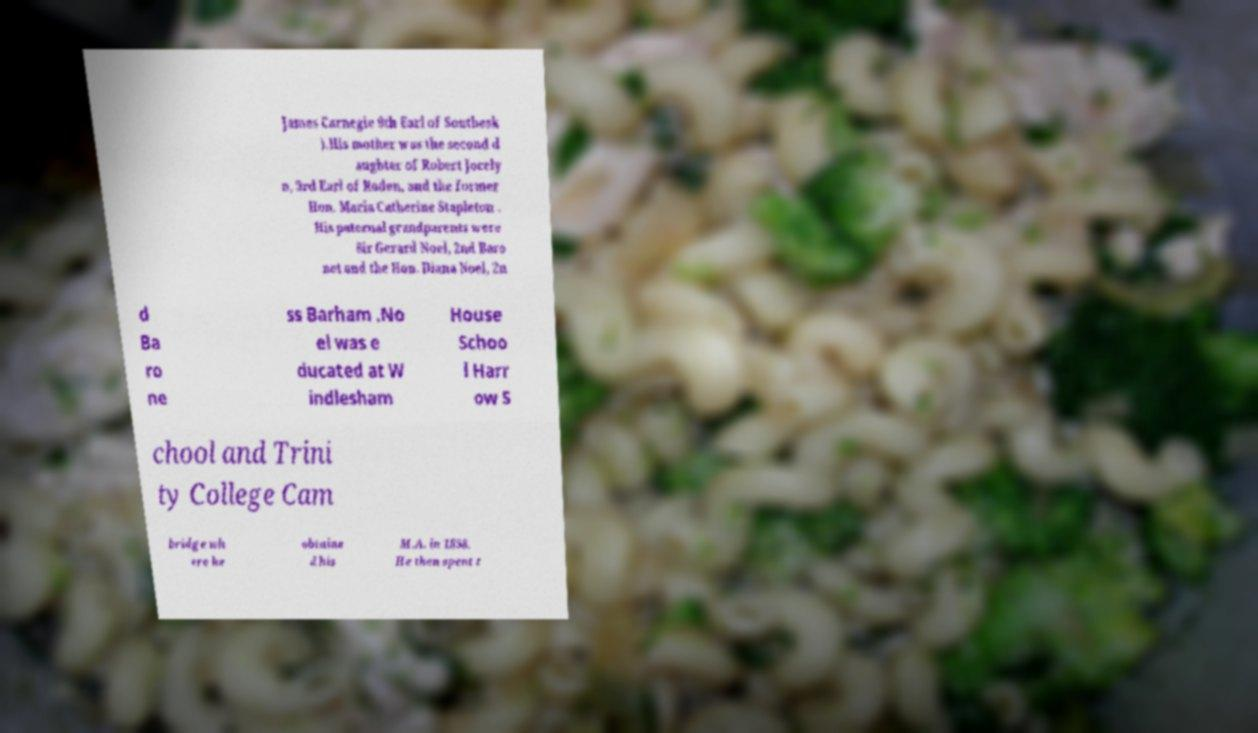For documentation purposes, I need the text within this image transcribed. Could you provide that? James Carnegie 9th Earl of Southesk ).His mother was the second d aughter of Robert Jocely n, 3rd Earl of Roden, and the former Hon. Maria Catherine Stapleton . His paternal grandparents were Sir Gerard Noel, 2nd Baro net and the Hon. Diana Noel, 2n d Ba ro ne ss Barham .No el was e ducated at W indlesham House Schoo l Harr ow S chool and Trini ty College Cam bridge wh ere he obtaine d his M.A. in 1858. He then spent t 